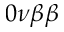<formula> <loc_0><loc_0><loc_500><loc_500>0 \nu \beta \beta</formula> 